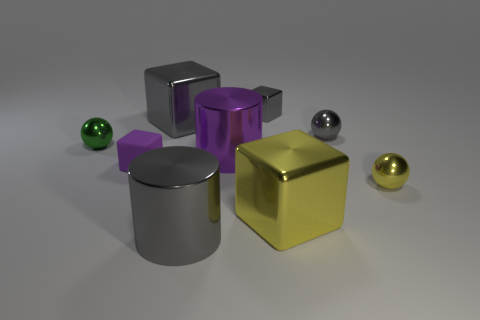Are there any other things that are made of the same material as the tiny purple thing? Yes, the tiny purple object appears to be made of the same shiny material as the other colored objects in the image. They all exhibit a reflective surface, which is indicative of being made out of a similar metallic or plastic material with a smooth finish. 